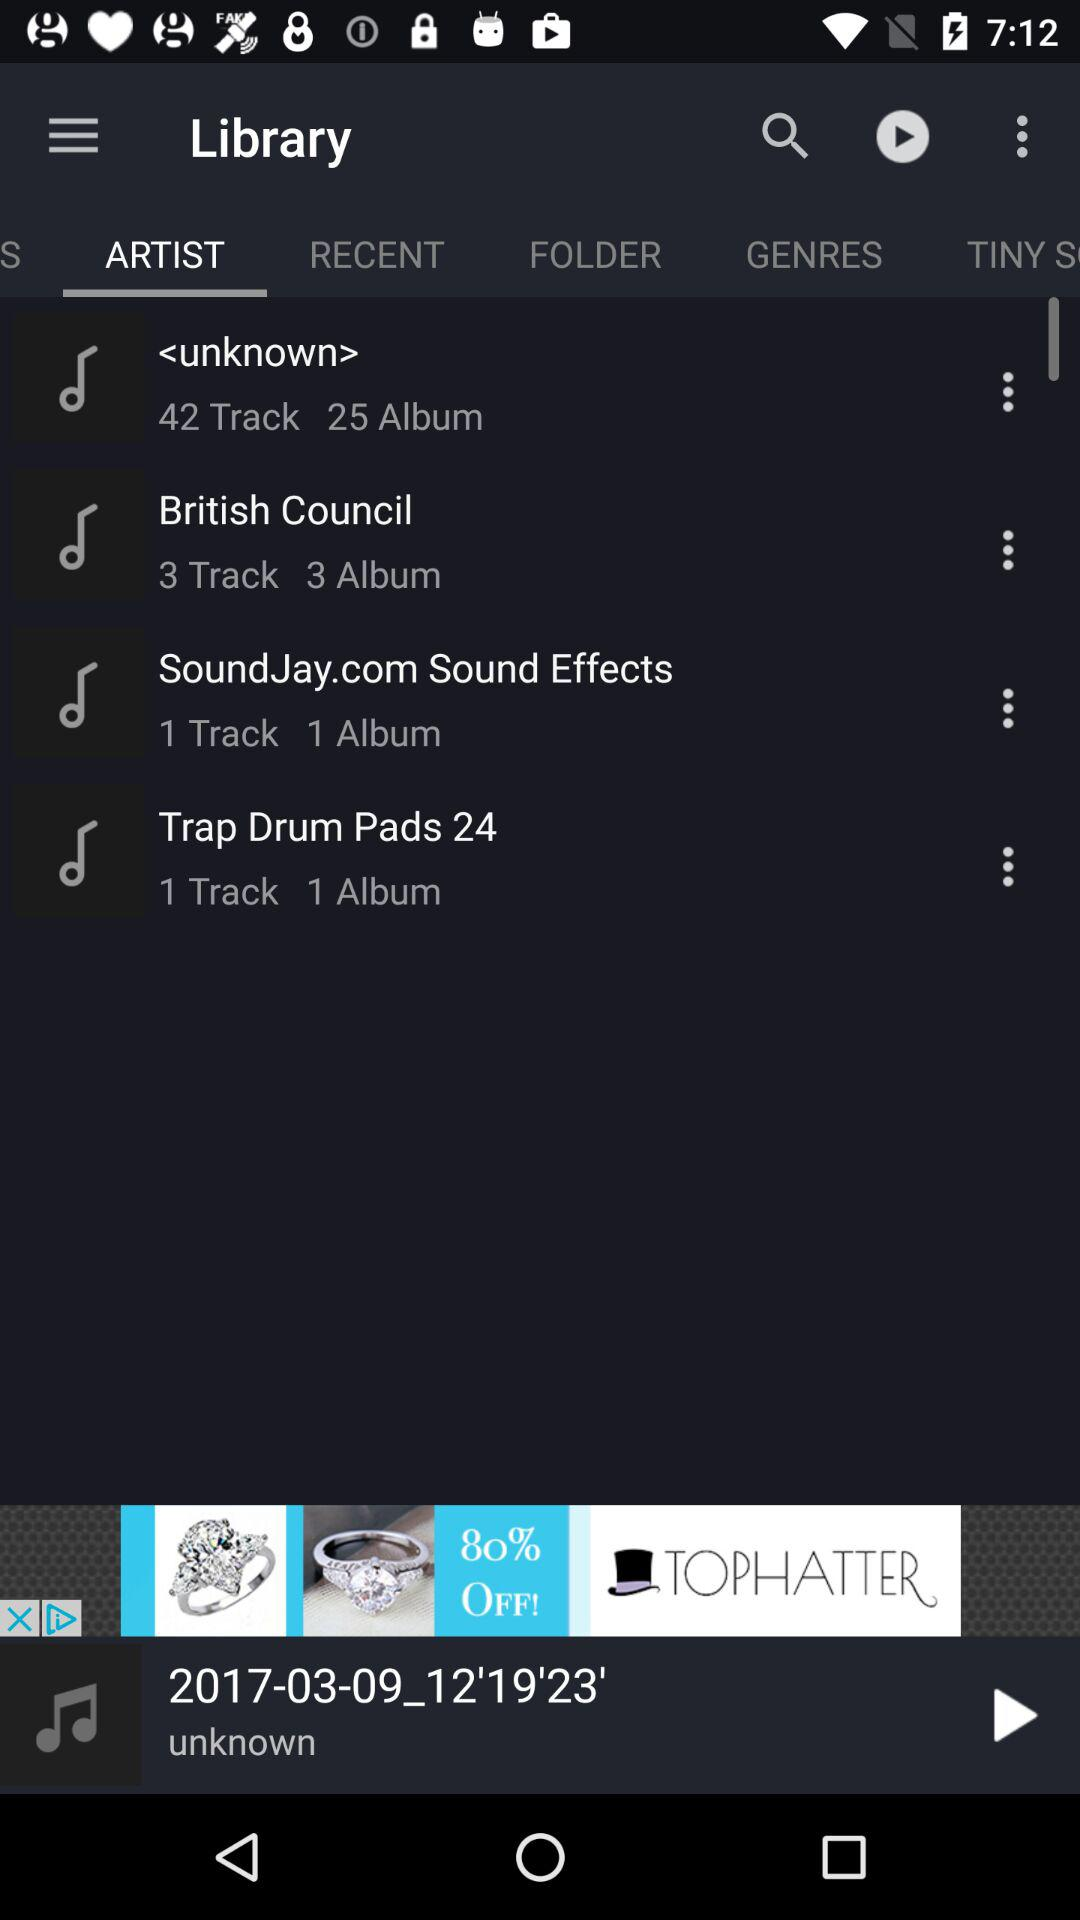How many tracks and albums are available by an unknown artist? There are 42 tracks and 25 albums available by an unknown artist. 